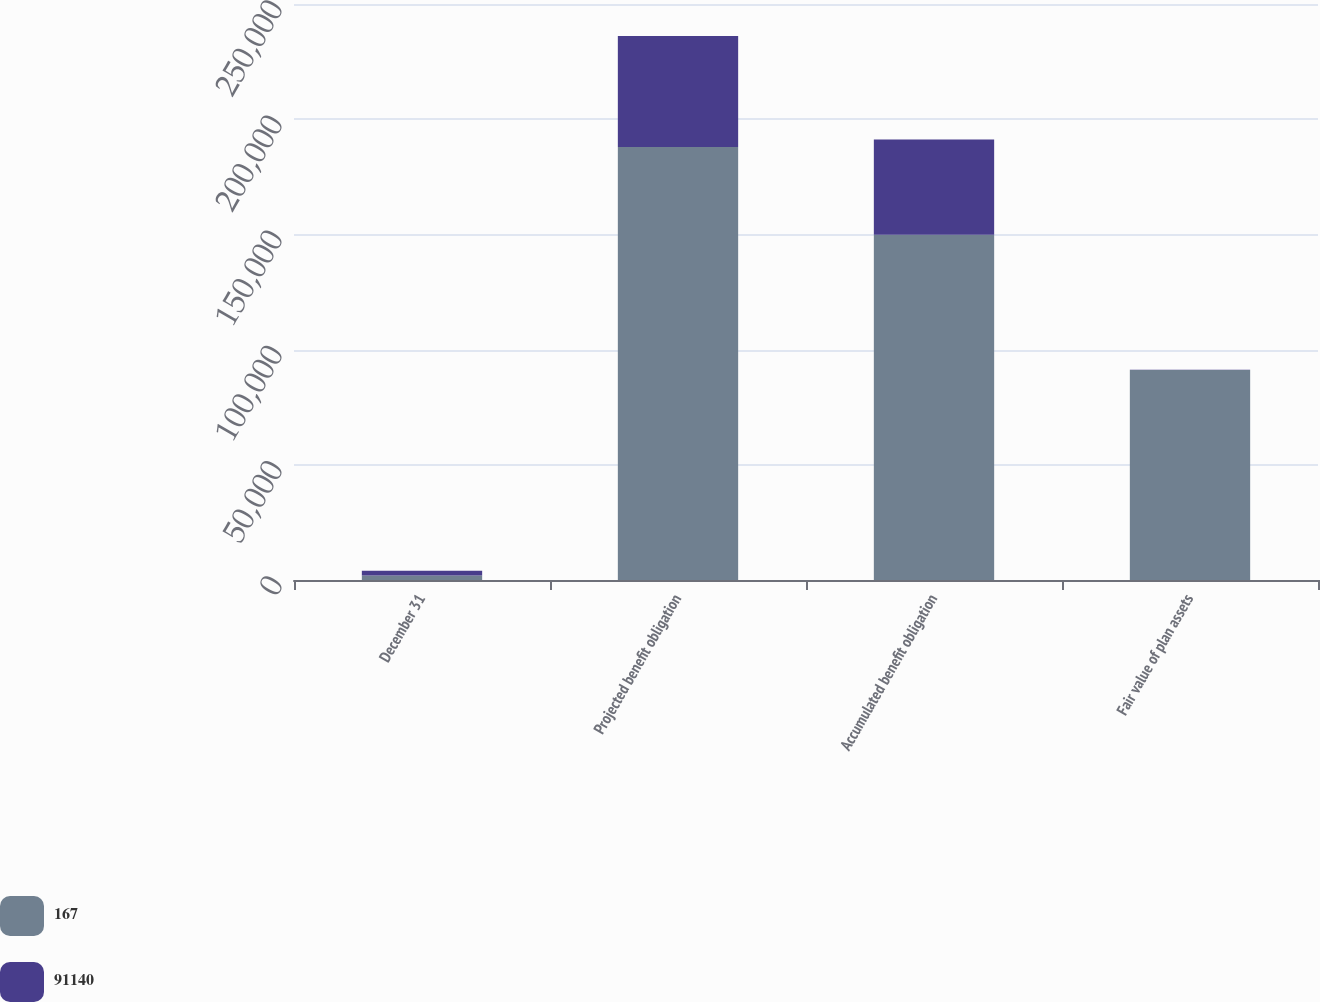Convert chart. <chart><loc_0><loc_0><loc_500><loc_500><stacked_bar_chart><ecel><fcel>December 31<fcel>Projected benefit obligation<fcel>Accumulated benefit obligation<fcel>Fair value of plan assets<nl><fcel>167<fcel>2005<fcel>187911<fcel>149840<fcel>91140<nl><fcel>91140<fcel>2004<fcel>48178<fcel>41366<fcel>167<nl></chart> 